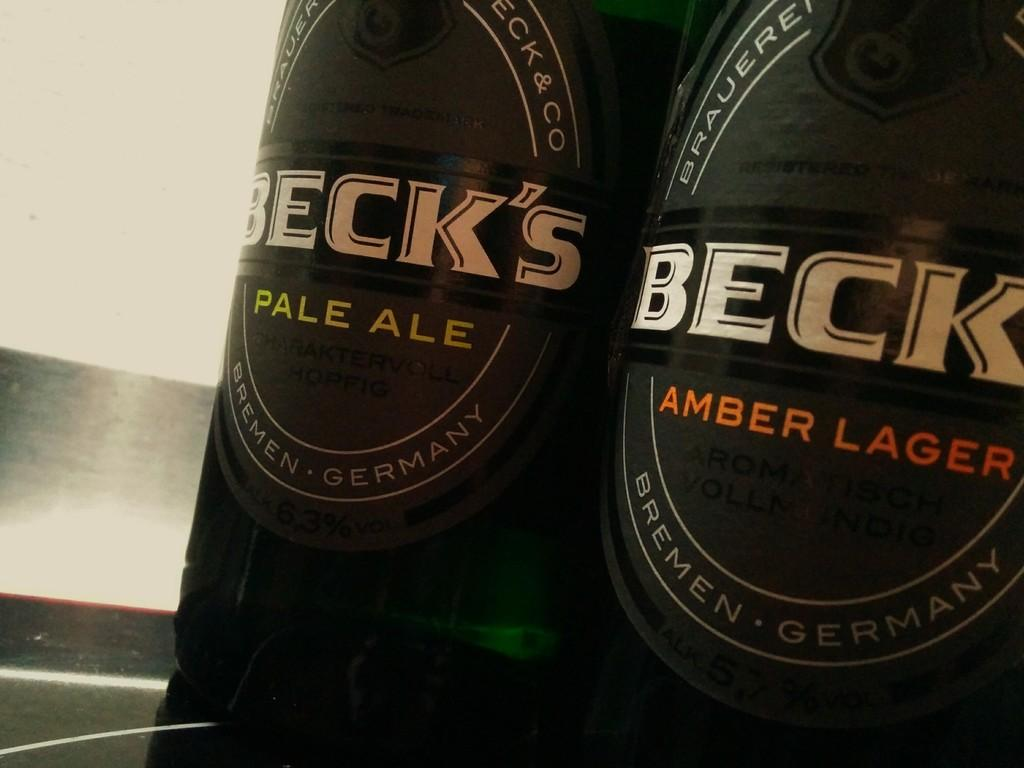<image>
Give a short and clear explanation of the subsequent image. Beck's Beer varieties include Pale Ale and Amber Lager. 